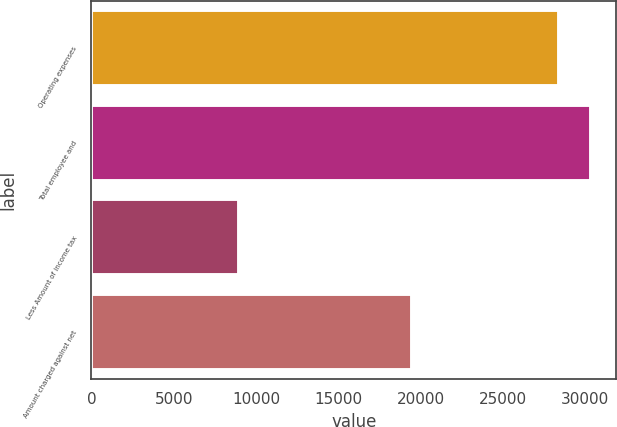<chart> <loc_0><loc_0><loc_500><loc_500><bar_chart><fcel>Operating expenses<fcel>Total employee and<fcel>Less Amount of income tax<fcel>Amount charged against net<nl><fcel>28413<fcel>30361<fcel>8933<fcel>19480<nl></chart> 